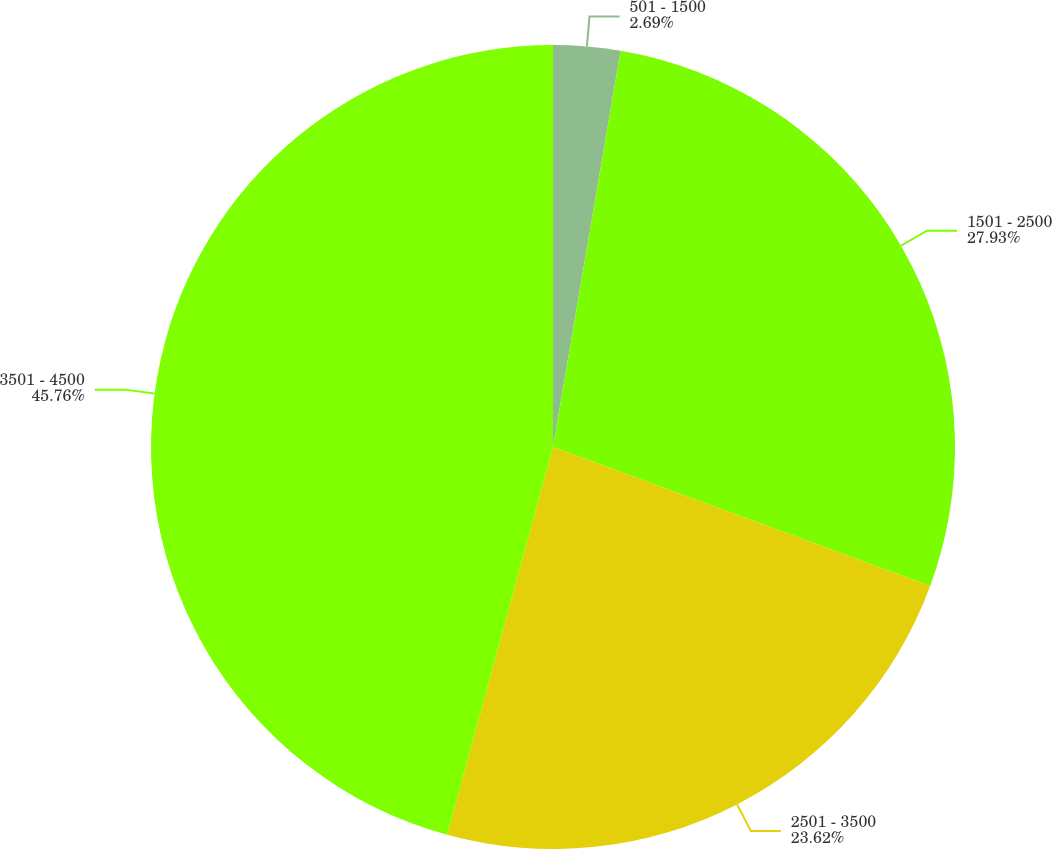Convert chart. <chart><loc_0><loc_0><loc_500><loc_500><pie_chart><fcel>501 - 1500<fcel>1501 - 2500<fcel>2501 - 3500<fcel>3501 - 4500<nl><fcel>2.69%<fcel>27.93%<fcel>23.62%<fcel>45.76%<nl></chart> 